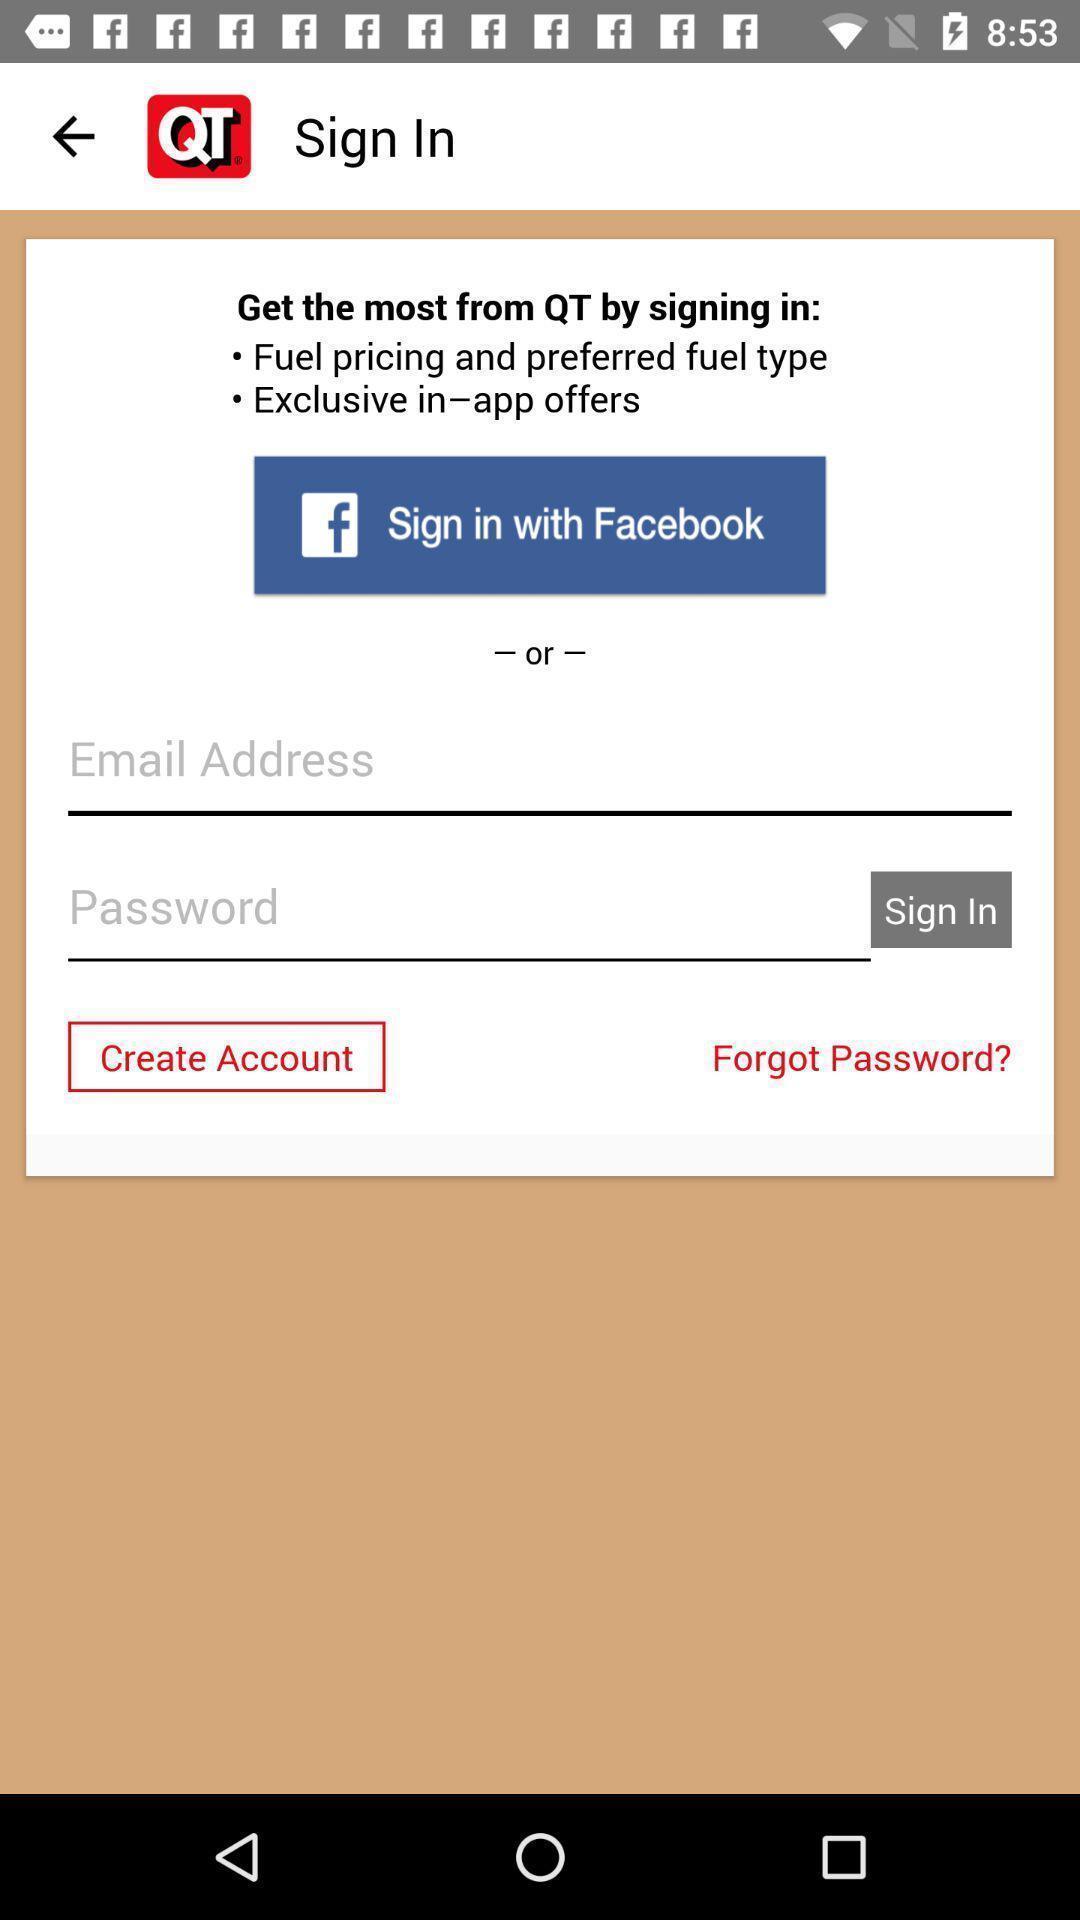Provide a description of this screenshot. Sign in page of a fuel pricing app. 